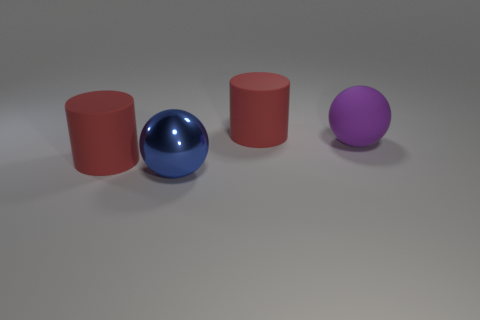Subtract all red cylinders. How many were subtracted if there are1red cylinders left? 1 Add 4 purple cylinders. How many objects exist? 8 Add 1 matte balls. How many matte balls are left? 2 Add 4 big red cylinders. How many big red cylinders exist? 6 Subtract 0 cyan cubes. How many objects are left? 4 Subtract all tiny purple matte spheres. Subtract all cylinders. How many objects are left? 2 